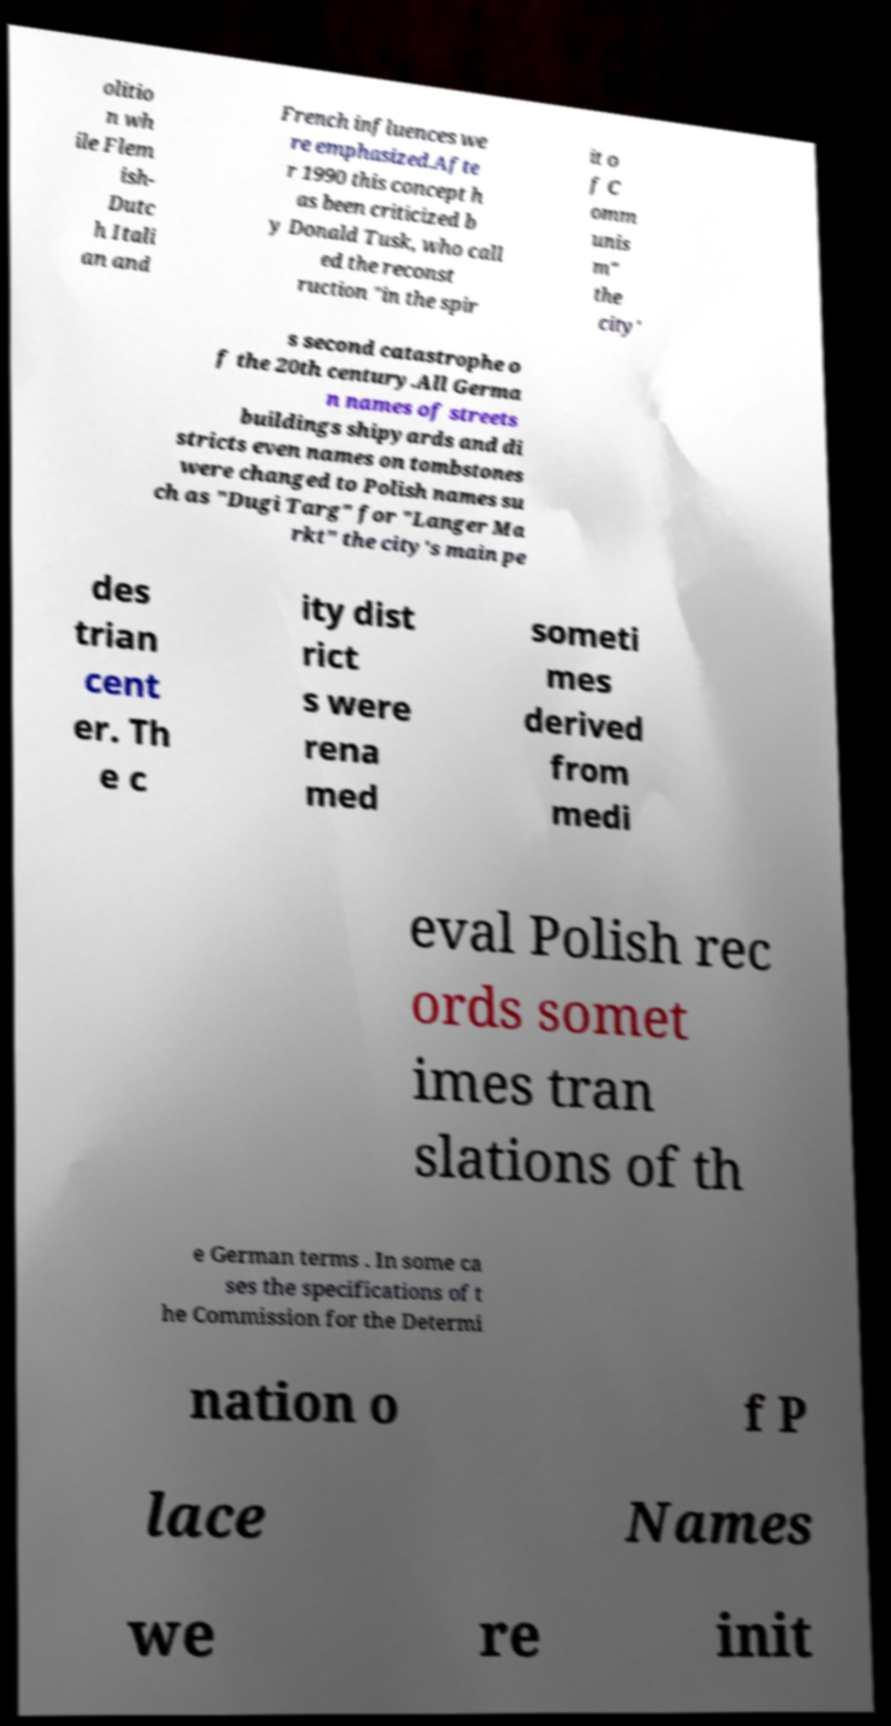There's text embedded in this image that I need extracted. Can you transcribe it verbatim? olitio n wh ile Flem ish- Dutc h Itali an and French influences we re emphasized.Afte r 1990 this concept h as been criticized b y Donald Tusk, who call ed the reconst ruction "in the spir it o f C omm unis m" the city' s second catastrophe o f the 20th century.All Germa n names of streets buildings shipyards and di stricts even names on tombstones were changed to Polish names su ch as "Dugi Targ" for "Langer Ma rkt" the city's main pe des trian cent er. Th e c ity dist rict s were rena med someti mes derived from medi eval Polish rec ords somet imes tran slations of th e German terms . In some ca ses the specifications of t he Commission for the Determi nation o f P lace Names we re init 